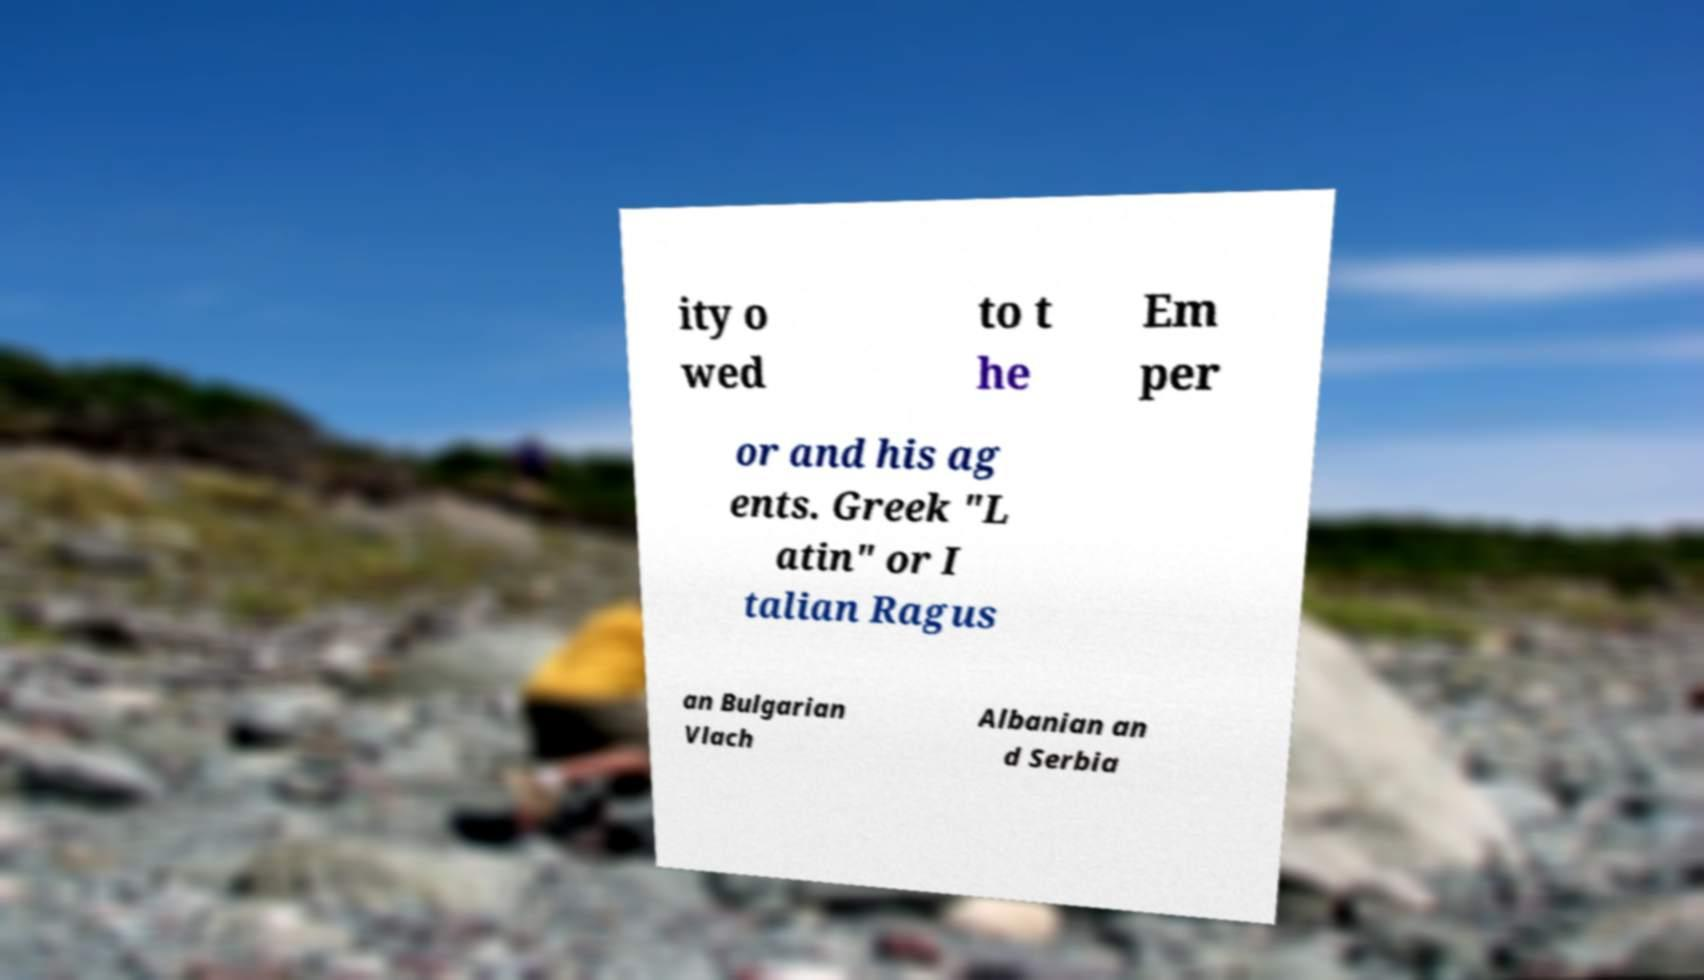For documentation purposes, I need the text within this image transcribed. Could you provide that? ity o wed to t he Em per or and his ag ents. Greek "L atin" or I talian Ragus an Bulgarian Vlach Albanian an d Serbia 